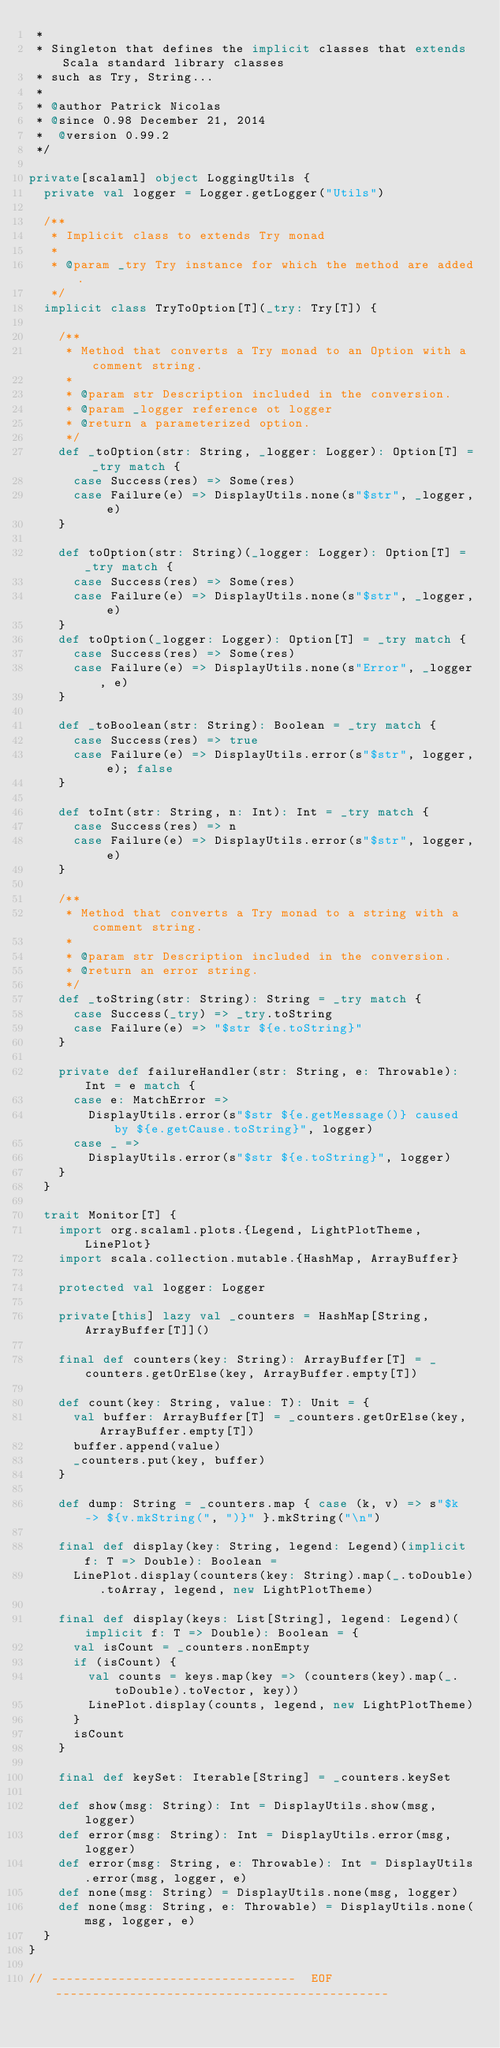Convert code to text. <code><loc_0><loc_0><loc_500><loc_500><_Scala_> *
 * Singleton that defines the implicit classes that extends Scala standard library classes
 * such as Try, String...
 *
 * @author Patrick Nicolas
 * @since 0.98 December 21, 2014
 *  @version 0.99.2
 */

private[scalaml] object LoggingUtils {
  private val logger = Logger.getLogger("Utils")

  /**
   * Implicit class to extends Try monad
   *
   * @param _try Try instance for which the method are added.
   */
  implicit class TryToOption[T](_try: Try[T]) {

    /**
     * Method that converts a Try monad to an Option with a comment string.
     *
     * @param str Description included in the conversion.
     * @param _logger reference ot logger
     * @return a parameterized option.
     */
    def _toOption(str: String, _logger: Logger): Option[T] = _try match {
      case Success(res) => Some(res)
      case Failure(e) => DisplayUtils.none(s"$str", _logger, e)
    }

    def toOption(str: String)(_logger: Logger): Option[T] = _try match {
      case Success(res) => Some(res)
      case Failure(e) => DisplayUtils.none(s"$str", _logger, e)
    }
    def toOption(_logger: Logger): Option[T] = _try match {
      case Success(res) => Some(res)
      case Failure(e) => DisplayUtils.none(s"Error", _logger, e)
    }

    def _toBoolean(str: String): Boolean = _try match {
      case Success(res) => true
      case Failure(e) => DisplayUtils.error(s"$str", logger, e); false
    }

    def toInt(str: String, n: Int): Int = _try match {
      case Success(res) => n
      case Failure(e) => DisplayUtils.error(s"$str", logger, e)
    }

    /**
     * Method that converts a Try monad to a string with a comment string.
     *
     * @param str Description included in the conversion.
     * @return an error string.
     */
    def _toString(str: String): String = _try match {
      case Success(_try) => _try.toString
      case Failure(e) => "$str ${e.toString}"
    }

    private def failureHandler(str: String, e: Throwable): Int = e match {
      case e: MatchError =>
        DisplayUtils.error(s"$str ${e.getMessage()} caused by ${e.getCause.toString}", logger)
      case _ =>
        DisplayUtils.error(s"$str ${e.toString}", logger)
    }
  }

  trait Monitor[T] {
    import org.scalaml.plots.{Legend, LightPlotTheme, LinePlot}
    import scala.collection.mutable.{HashMap, ArrayBuffer}

    protected val logger: Logger

    private[this] lazy val _counters = HashMap[String, ArrayBuffer[T]]()

    final def counters(key: String): ArrayBuffer[T] = _counters.getOrElse(key, ArrayBuffer.empty[T])

    def count(key: String, value: T): Unit = {
      val buffer: ArrayBuffer[T] = _counters.getOrElse(key, ArrayBuffer.empty[T])
      buffer.append(value)
      _counters.put(key, buffer)
    }

    def dump: String = _counters.map { case (k, v) => s"$k -> ${v.mkString(", ")}" }.mkString("\n")

    final def display(key: String, legend: Legend)(implicit f: T => Double): Boolean =
      LinePlot.display(counters(key: String).map(_.toDouble).toArray, legend, new LightPlotTheme)

    final def display(keys: List[String], legend: Legend)(implicit f: T => Double): Boolean = {
      val isCount = _counters.nonEmpty
      if (isCount) {
        val counts = keys.map(key => (counters(key).map(_.toDouble).toVector, key))
        LinePlot.display(counts, legend, new LightPlotTheme)
      }
      isCount
    }

    final def keySet: Iterable[String] = _counters.keySet

    def show(msg: String): Int = DisplayUtils.show(msg, logger)
    def error(msg: String): Int = DisplayUtils.error(msg, logger)
    def error(msg: String, e: Throwable): Int = DisplayUtils.error(msg, logger, e)
    def none(msg: String) = DisplayUtils.none(msg, logger)
    def none(msg: String, e: Throwable) = DisplayUtils.none(msg, logger, e)
  }
}

// ---------------------------------  EOF ---------------------------------------------</code> 